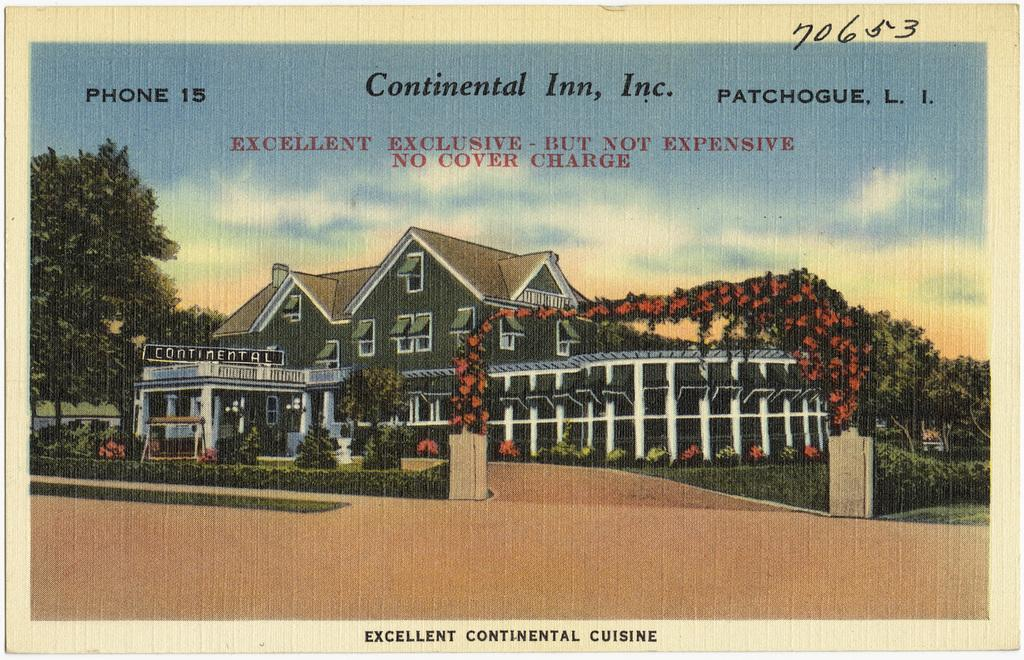What is the main subject of the image? There is a photograph of a building in the image. What is located in front of the building? There are plants, bushes, and grass on the surface in front of the building. What can be seen in the background of the image? There are trees and the sky visible in the background of the image. What type of disease is affecting the trees in the image? There is no indication of any disease affecting the trees in the image; they appear healthy. What type of support is provided by the bushes in the image? The bushes in the image are not providing any support; they are simply part of the landscape. 